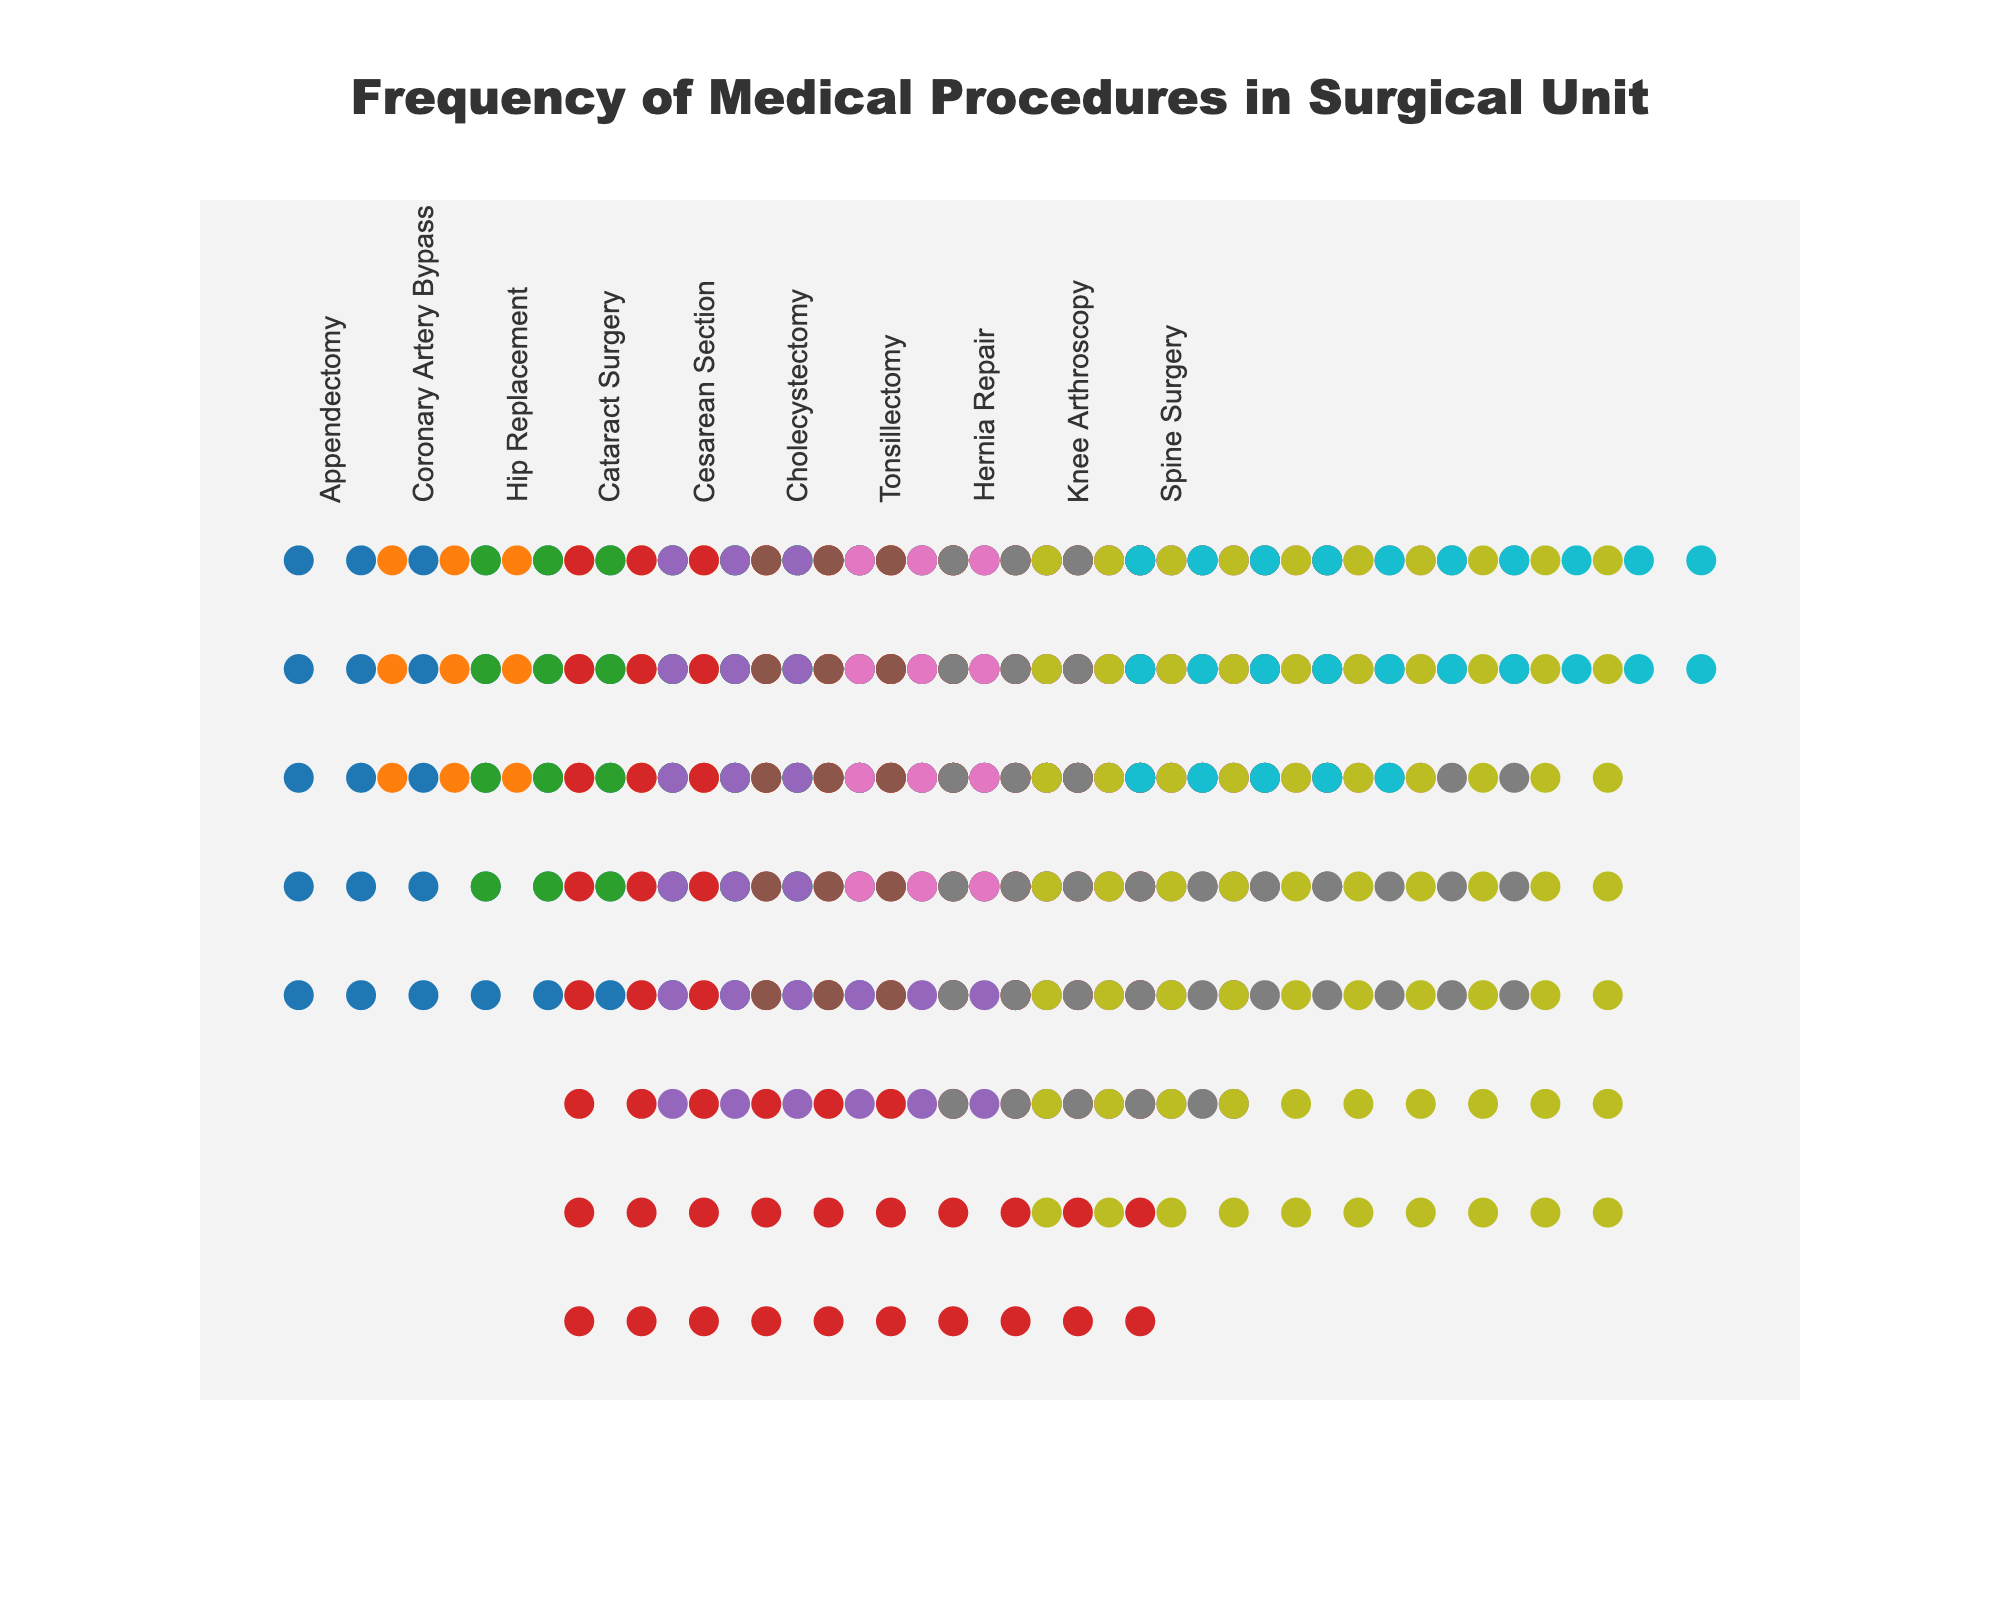What is the title of the figure? The title is usually displayed prominently at the top of the figure. It helps to understand the overall subject of the plot. In the provided plot, the title clearly states "Frequency of Medical Procedures in Surgical Unit".
Answer: Frequency of Medical Procedures in Surgical Unit How many dots represent an appendectomy? Count the number of dots for the procedure labeled as "Appendectomy". Each dot represents one instance. The figure shows 50 dots for Appendectomy.
Answer: 50 Which procedure is performed most frequently? Identify the procedure name with the highest count of dots. The longest row of icons corresponds to "Cataract Surgery", which has 80 dots.
Answer: Cataract Surgery Which procedures have counts greater than 50? Look at each procedure and count the number of dots. Those with more than 50 dots are listed. "Cataract Surgery", "Cesarean Section", "Knee Arthroscopy", and "Hernia Repair" all meet this criterion.
Answer: Cataract Surgery, Cesarean Section, Knee Arthroscopy, Hernia Repair Which procedure has the least number of occurrences? Identify the procedure with the fewest dots. By inspecting, "Spine Surgery" with 25 dots is the procedure with least occurrences.
Answer: Spine Surgery What is the total number of procedures performed? Sum up the counts of occurrences for all procedures. The total is computed as 50 + 30 + 40 + 80 + 60 + 45 + 35 + 55 + 70 + 25 = 490.
Answer: 490 How many more times is Cataract Surgery performed compared to Spine Surgery? Find the difference in the number of dots between "Cataract Surgery" and "Spine Surgery". The difference is 80 - 25 = 55.
Answer: 55 Are there any procedures with exactly 35 occurrences? If so, which one? Count the dots and find any which exactly match 35. The procedure "Tonsillectomy" has exactly 35 occurrences.
Answer: Tonsillectomy What is the median occurrence of all procedures? List all counts (25, 30, 35, 40, 45, 50, 55, 60, 70, 80) and find the middle value. Since there are 10 values, the median is the average of the 5th and 6th values: (45 + 50) / 2 = 47.5.
Answer: 47.5 How does the frequency of Coronary Artery Bypass compare to Cholecystectomy? Compare the counts for these two procedures. Coronary Artery Bypass has 30 occurrences while Cholecystectomy has 45 occurrences, so Cholecystectomy is performed more frequently.
Answer: Cholecystectomy 